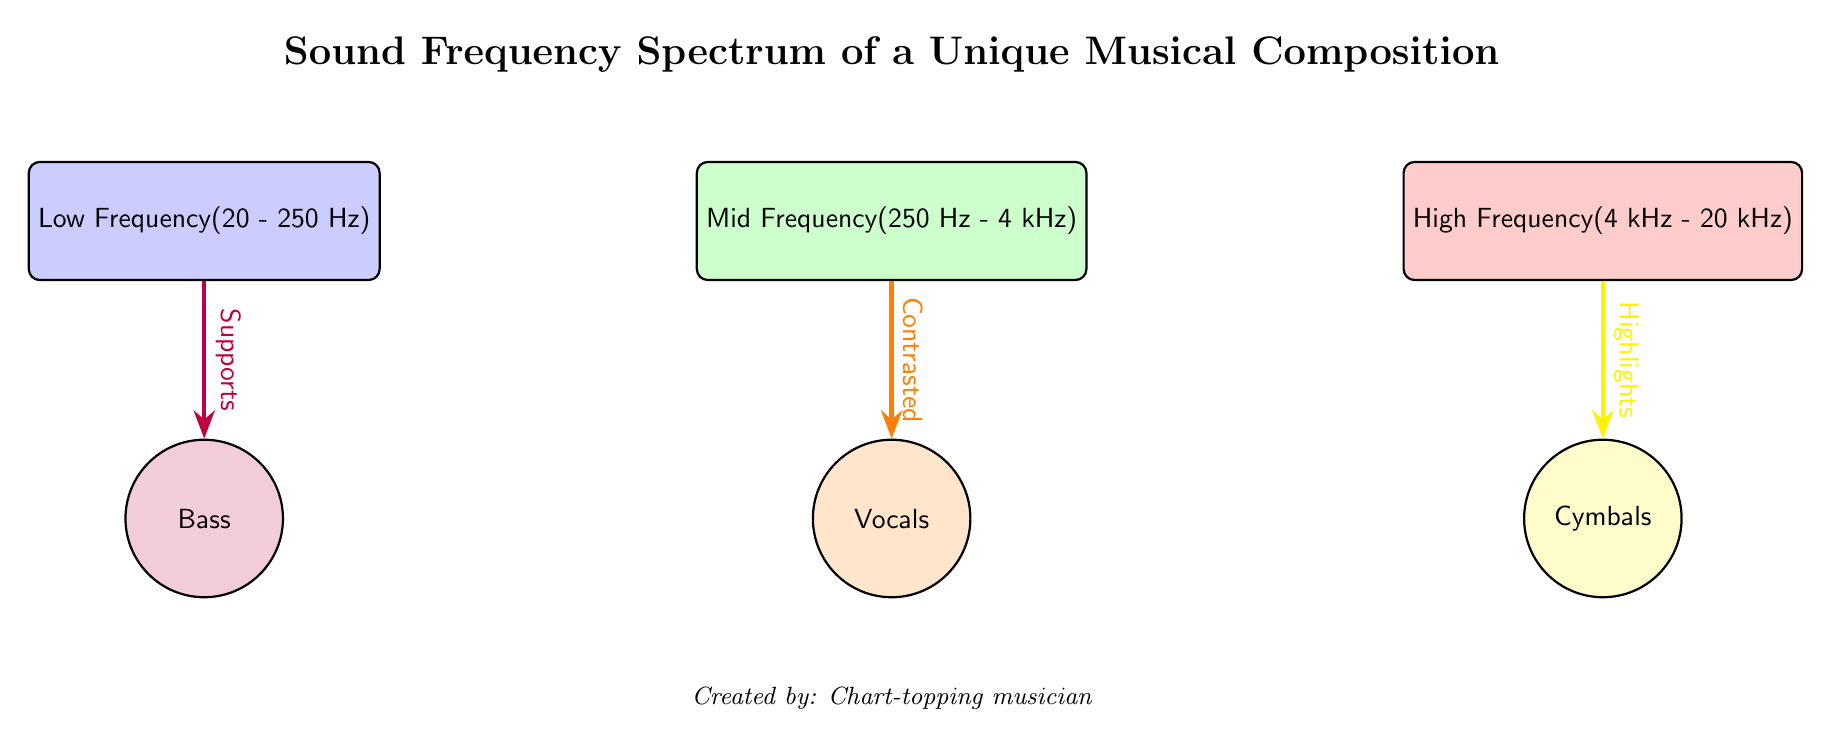What are the frequency ranges represented in the diagram? The diagram includes three frequency ranges: Low Frequency (20 - 250 Hz), Mid Frequency (250 Hz - 4 kHz), and High Frequency (4 kHz - 20 kHz). These ranges are labeled on the respective frequency nodes.
Answer: Low Frequency, Mid Frequency, High Frequency Which musical element is associated with low frequency? The diagram shows an arrow labeled "Supports" going from the Low Frequency node to the Bass element, indicating that Bass is associated with low frequency.
Answer: Bass How many nodes are present in the frequency spectrum section of the diagram? There are three nodes in the frequency spectrum section: Low Frequency, Mid Frequency, and High Frequency. Since we're focusing on the frequency range nodes only, we count these three.
Answer: 3 What role do vocals play in the mid frequency range? The arrow connecting the Mid Frequency node to the Vocals element is labeled "Contrasted," indicating that Vocals are contrasted within the mid frequency range.
Answer: Contrasted Which musical element highlights high frequency? The diagram shows an arrow labeled "Highlights" pointing from the High Frequency node to the Cymbals element. This clearly indicates that Cymbals highlight high frequency.
Answer: Cymbals What is the relationship between bass and low frequency? The diagram features an arrow labeled "Supports" that connects the Low Frequency node to the Bass element. This indicates that low frequency supports bass in the musical composition.
Answer: Supports In total, how many elements are represented in the diagram? The diagram comprises three musical elements: Bass, Vocals, and Cymbals. Since we are looking at elements alone, we total these three elements.
Answer: 3 What is the creator's designation mentioned in the diagram? The created information at the bottom of the diagram states "Chart-topping musician," discernible as the creator's designation.
Answer: Chart-topping musician 